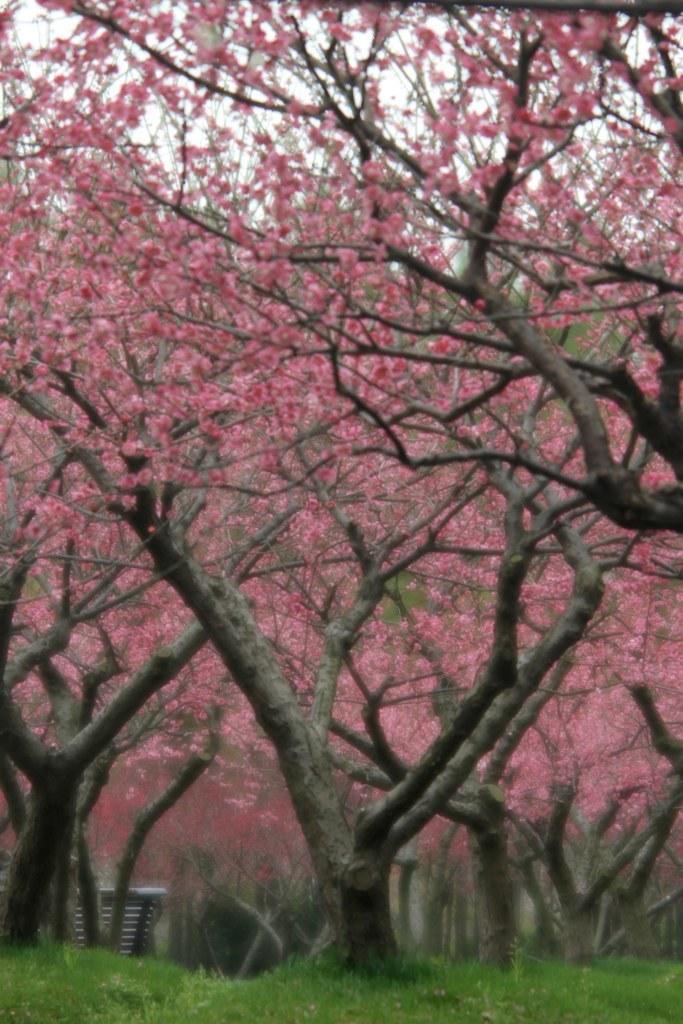In one or two sentences, can you explain what this image depicts? In this image I can see an open grass ground and number of trees. I can also see pink flowers and on the top side of this image I can see this the sky. 